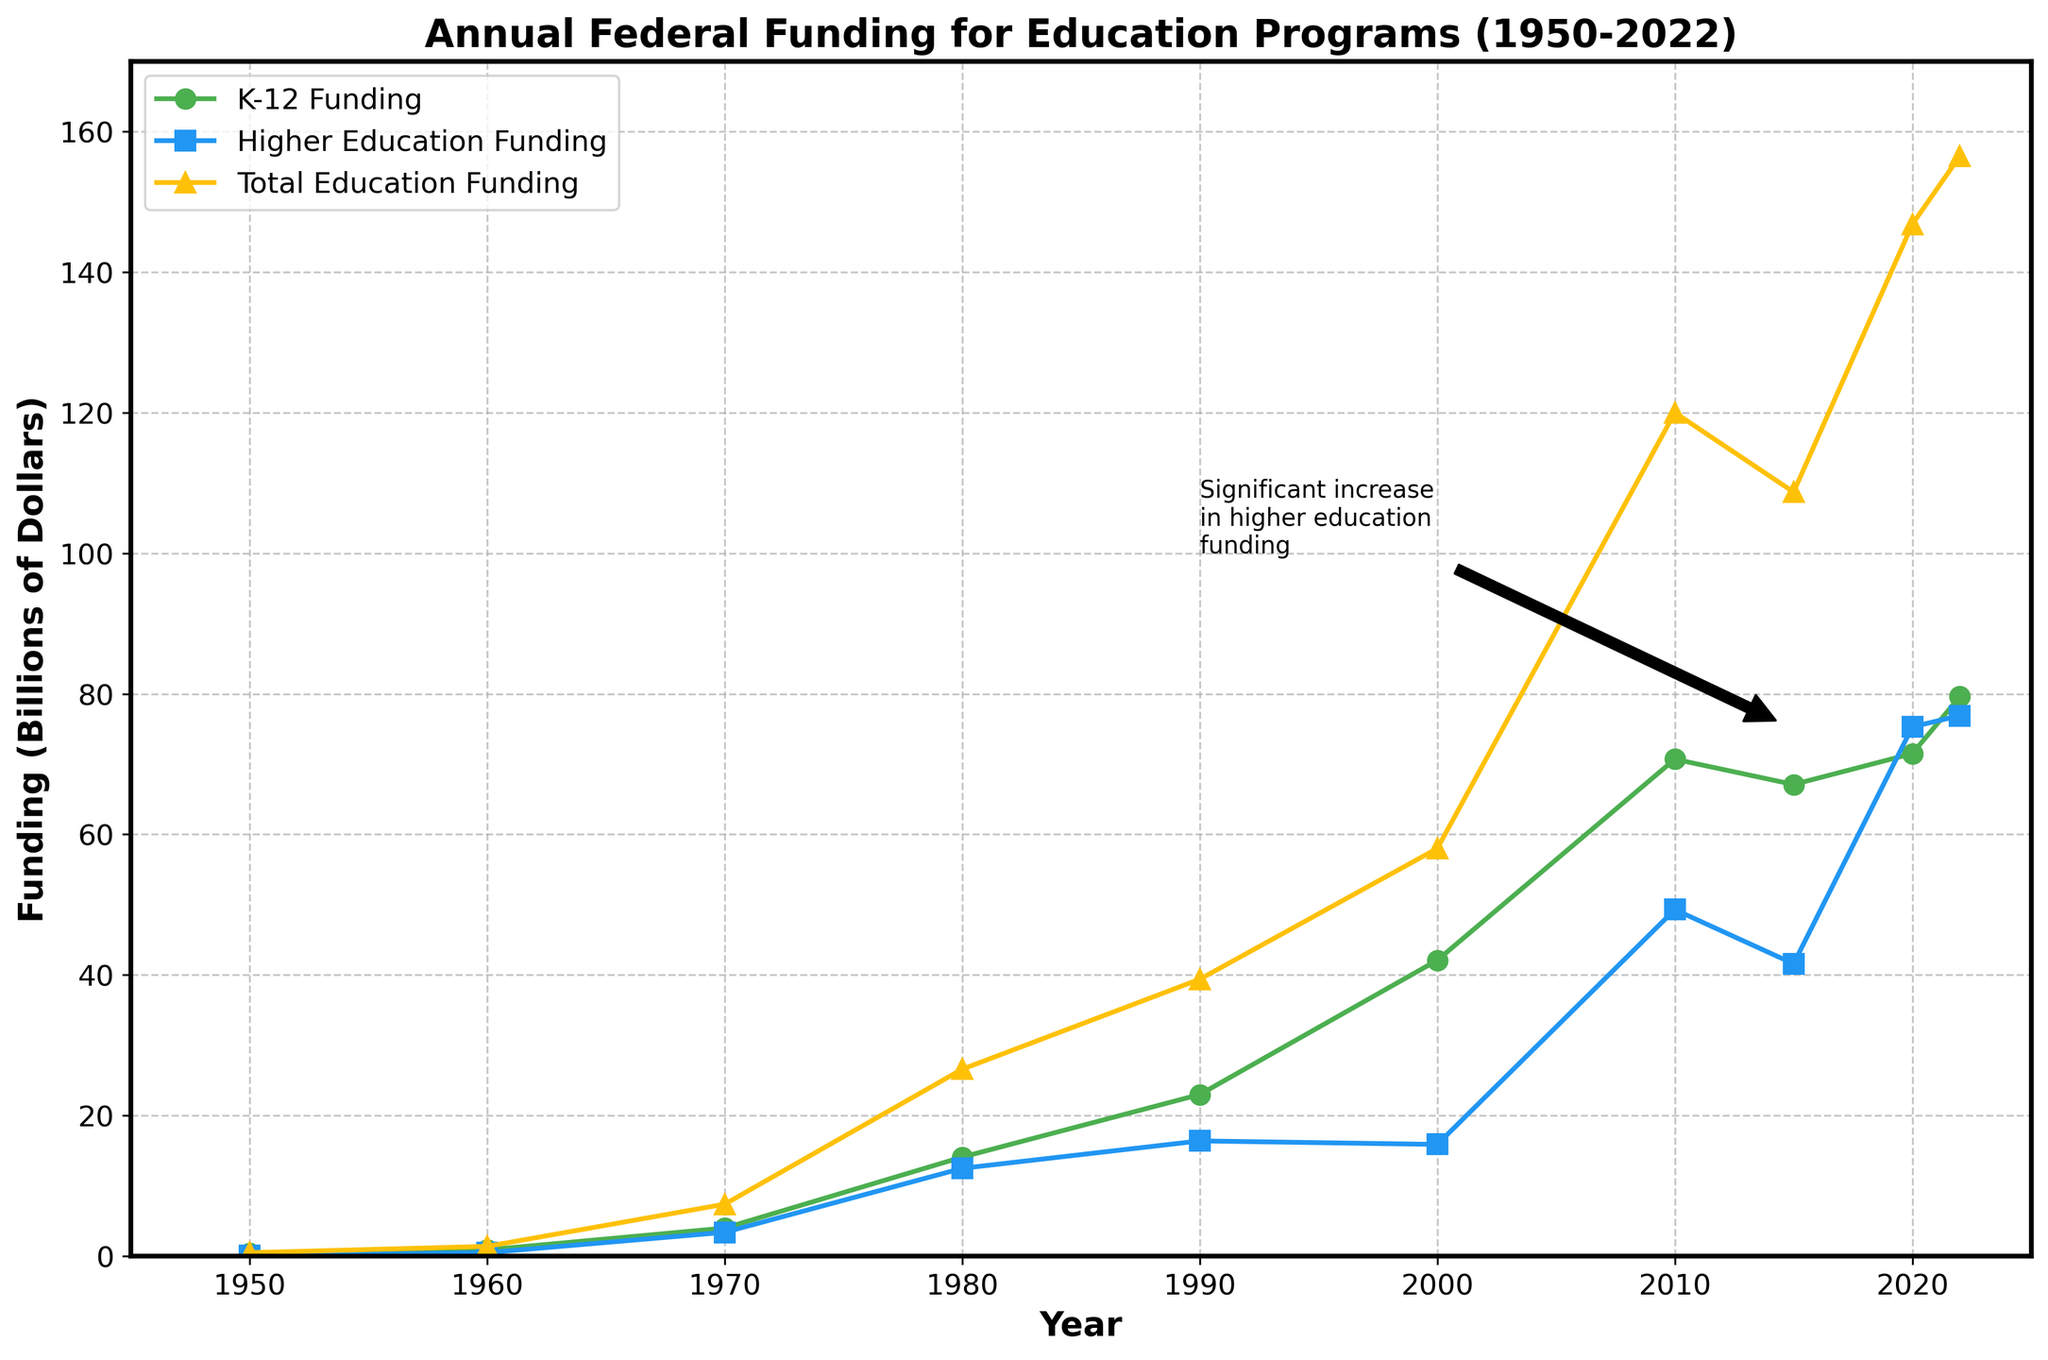What is the total education funding in 2022? By looking at the "Total Education Funding" line on the chart, which is the yellow line marked with triangles, we see that it reaches the point corresponding to the year 2022 on the x-axis. The label next to it reads $156.5 billion.
Answer: $156.5 billion How much higher was the K-12 funding in 2022 compared to 1950? First, locate the "K-12 Funding" line, which is marked with circles and is green. Find the values for the years 1950 and 2022. In 1950, K-12 funding was $0.4 billion, and in 2022, it was $79.6 billion. The difference is $79.6 billion - $0.4 billion = $79.2 billion.
Answer: $79.2 billion Which year saw a significant increase in higher education funding and is annotated on the chart? Look for any annotations or arrows pointing to significant events. There is one annotation that mentions a "Significant increase in higher education funding" around the year 2015.
Answer: 2015 In which decade did the total education funding exceed $50 billion for the first time? Trace the yellow line marking the "Total Education Funding" and see when it first crosses the $50 billion mark on the y-axis. This occurred around the year 2000.
Answer: 2000s Compare the total education funding between 1990 and 2020. Which year had the higher funding, and by how much? Refer to the yellow line. In 1990, the total education funding was $39.4 billion. In 2020, it was $146.8 billion. The difference is $146.8 billion - $39.4 billion = $107.4 billion.
Answer: 2020 by $107.4 billion What is the approximate average K-12 funding for the years 1950, 1960, and 1970? Find the values for the years 1950, 1960, and 1970 on the green K-12 Funding line. They are $0.4 billion, $0.9 billion, and $4.0 billion, respectively. The average is calculated as: (0.4 + 0.9 + 4.0) / 3 ≈ 1.77 billion.
Answer: ≈ 1.77 billion Visual comparison: Which funding type saw a more substantial increase between 1980 and 2020? Compare the steepness and vertical change of the two lines. For K-12 (green line), it went from $14.1 billion to $71.5 billion (an increase of $57.4 billion). For Higher Education (blue line), it went from $12.5 billion to $75.3 billion (an increase of $62.8 billion). So, higher education funding saw a more substantial increase.
Answer: Higher education Determine the average total education funding from 1950 to 2022. The total education funding values are: $0.5, $1.4, $7.4, $26.6, $39.4, $58.0, $120.0, $108.7, $146.8, and $156.5 billion. Summing them up: $0.5 + $1.4 + $7.4 + $26.6 + $39.4 + $58.0 + $120.0 + $108.7 + $146.8 + $156.5 = $665.3 billion. There are 10 values, so divide by 10: $665.3 billion / 10 = $66.53 billion.
Answer: $66.53 billion Which funding type has more variability over the years, K-12 or Higher Education? Visualize the fluctuations in both lines; the blue line (Higher Education) has sharper increases and decreases. This variability can be inferred by observing more pronounced peaks and troughs compared to the greener K-12 line.
Answer: Higher Education 